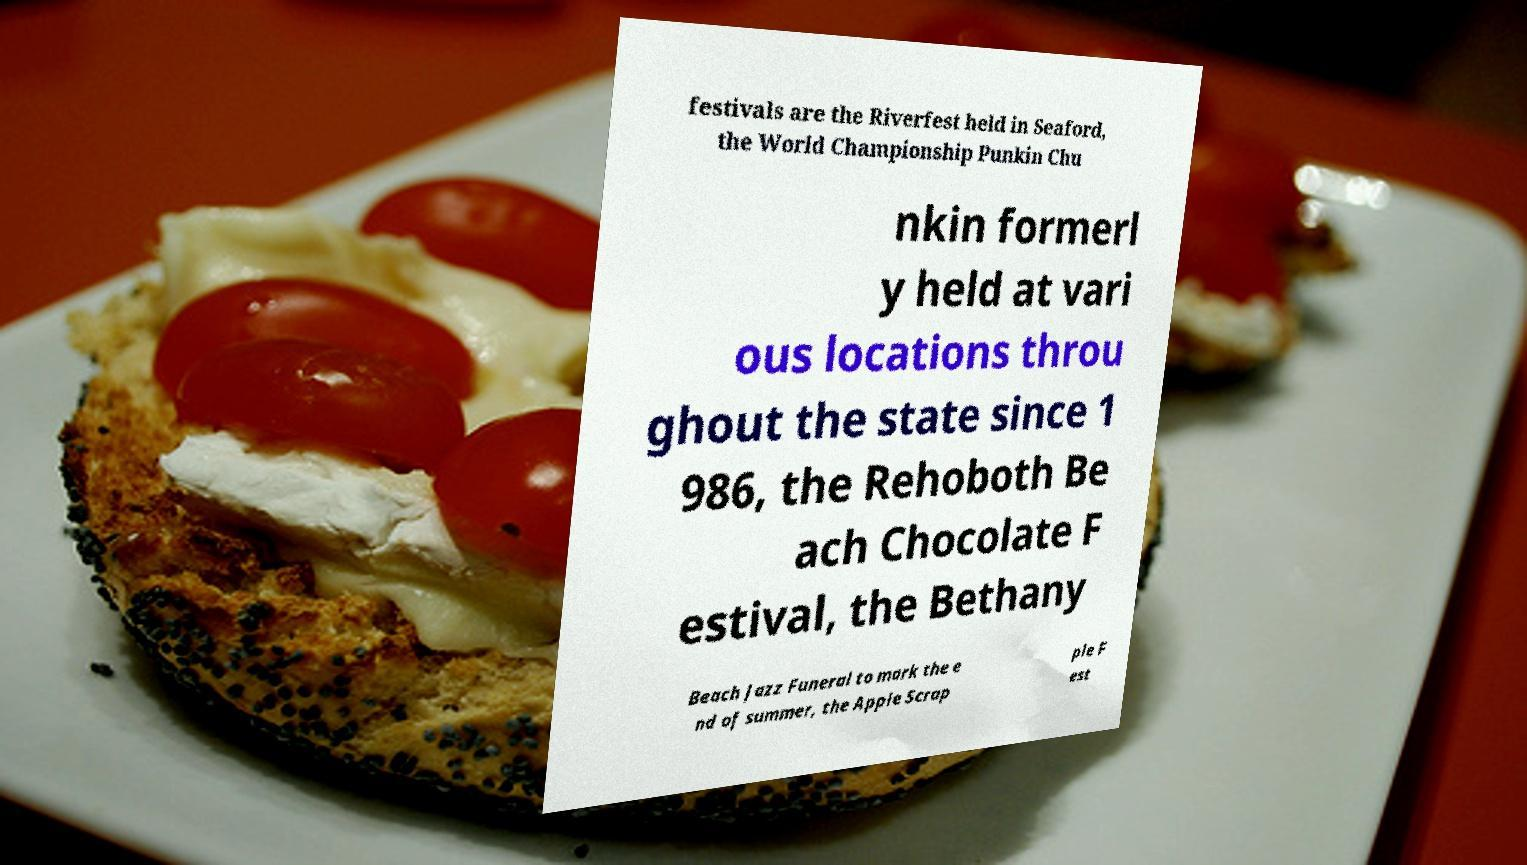Can you accurately transcribe the text from the provided image for me? festivals are the Riverfest held in Seaford, the World Championship Punkin Chu nkin formerl y held at vari ous locations throu ghout the state since 1 986, the Rehoboth Be ach Chocolate F estival, the Bethany Beach Jazz Funeral to mark the e nd of summer, the Apple Scrap ple F est 